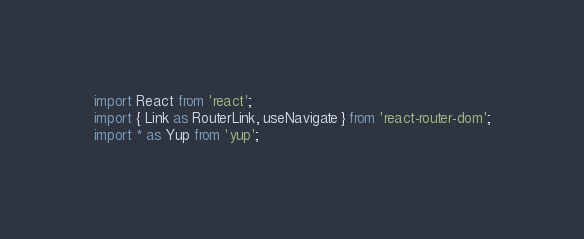<code> <loc_0><loc_0><loc_500><loc_500><_JavaScript_>import React from 'react';
import { Link as RouterLink, useNavigate } from 'react-router-dom';
import * as Yup from 'yup';</code> 